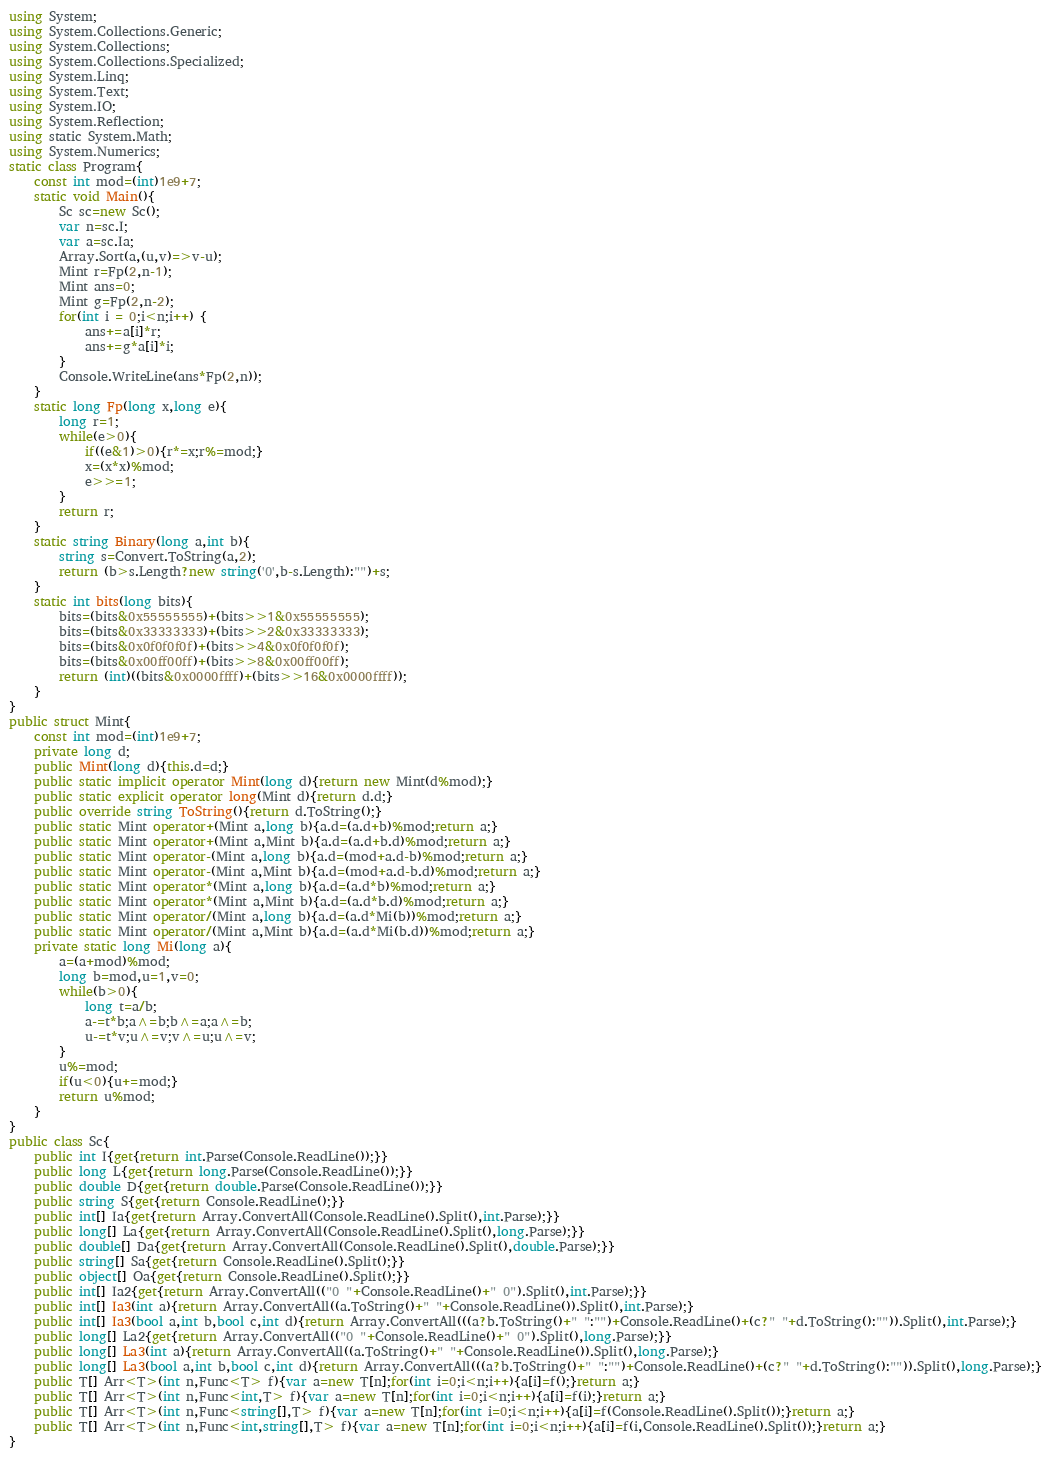<code> <loc_0><loc_0><loc_500><loc_500><_C#_>using System;
using System.Collections.Generic;
using System.Collections;
using System.Collections.Specialized;
using System.Linq;
using System.Text;
using System.IO;
using System.Reflection;
using static System.Math;
using System.Numerics;
static class Program{
	const int mod=(int)1e9+7;
	static void Main(){
		Sc sc=new Sc();
		var n=sc.I;
		var a=sc.Ia;
		Array.Sort(a,(u,v)=>v-u);
		Mint r=Fp(2,n-1);
		Mint ans=0;
		Mint g=Fp(2,n-2);
		for(int i = 0;i<n;i++) {
			ans+=a[i]*r;
			ans+=g*a[i]*i;
		}
		Console.WriteLine(ans*Fp(2,n));
	}
	static long Fp(long x,long e){
		long r=1;
		while(e>0){
			if((e&1)>0){r*=x;r%=mod;}
			x=(x*x)%mod;
			e>>=1;
		}
		return r;
	}
	static string Binary(long a,int b){
		string s=Convert.ToString(a,2);
		return (b>s.Length?new string('0',b-s.Length):"")+s;
	}
	static int bits(long bits){
		bits=(bits&0x55555555)+(bits>>1&0x55555555);
		bits=(bits&0x33333333)+(bits>>2&0x33333333);
		bits=(bits&0x0f0f0f0f)+(bits>>4&0x0f0f0f0f);
		bits=(bits&0x00ff00ff)+(bits>>8&0x00ff00ff);
		return (int)((bits&0x0000ffff)+(bits>>16&0x0000ffff));
	}
}
public struct Mint{
	const int mod=(int)1e9+7;
	private long d;
	public Mint(long d){this.d=d;}
	public static implicit operator Mint(long d){return new Mint(d%mod);}
	public static explicit operator long(Mint d){return d.d;}
	public override string ToString(){return d.ToString();}
	public static Mint operator+(Mint a,long b){a.d=(a.d+b)%mod;return a;}
	public static Mint operator+(Mint a,Mint b){a.d=(a.d+b.d)%mod;return a;}
	public static Mint operator-(Mint a,long b){a.d=(mod+a.d-b)%mod;return a;}
	public static Mint operator-(Mint a,Mint b){a.d=(mod+a.d-b.d)%mod;return a;}
	public static Mint operator*(Mint a,long b){a.d=(a.d*b)%mod;return a;}
	public static Mint operator*(Mint a,Mint b){a.d=(a.d*b.d)%mod;return a;}
	public static Mint operator/(Mint a,long b){a.d=(a.d*Mi(b))%mod;return a;}
	public static Mint operator/(Mint a,Mint b){a.d=(a.d*Mi(b.d))%mod;return a;}
	private static long Mi(long a){
		a=(a+mod)%mod;
		long b=mod,u=1,v=0;
		while(b>0){
			long t=a/b;
			a-=t*b;a^=b;b^=a;a^=b;
			u-=t*v;u^=v;v^=u;u^=v;
		}
		u%=mod;
		if(u<0){u+=mod;}
		return u%mod;
	}
}
public class Sc{
	public int I{get{return int.Parse(Console.ReadLine());}}
	public long L{get{return long.Parse(Console.ReadLine());}}
	public double D{get{return double.Parse(Console.ReadLine());}}
	public string S{get{return Console.ReadLine();}}
	public int[] Ia{get{return Array.ConvertAll(Console.ReadLine().Split(),int.Parse);}}
	public long[] La{get{return Array.ConvertAll(Console.ReadLine().Split(),long.Parse);}}
	public double[] Da{get{return Array.ConvertAll(Console.ReadLine().Split(),double.Parse);}}
	public string[] Sa{get{return Console.ReadLine().Split();}}
	public object[] Oa{get{return Console.ReadLine().Split();}}
	public int[] Ia2{get{return Array.ConvertAll(("0 "+Console.ReadLine()+" 0").Split(),int.Parse);}}
	public int[] Ia3(int a){return Array.ConvertAll((a.ToString()+" "+Console.ReadLine()).Split(),int.Parse);}
	public int[] Ia3(bool a,int b,bool c,int d){return Array.ConvertAll(((a?b.ToString()+" ":"")+Console.ReadLine()+(c?" "+d.ToString():"")).Split(),int.Parse);}
	public long[] La2{get{return Array.ConvertAll(("0 "+Console.ReadLine()+" 0").Split(),long.Parse);}}
	public long[] La3(int a){return Array.ConvertAll((a.ToString()+" "+Console.ReadLine()).Split(),long.Parse);}
	public long[] La3(bool a,int b,bool c,int d){return Array.ConvertAll(((a?b.ToString()+" ":"")+Console.ReadLine()+(c?" "+d.ToString():"")).Split(),long.Parse);}
	public T[] Arr<T>(int n,Func<T> f){var a=new T[n];for(int i=0;i<n;i++){a[i]=f();}return a;}
	public T[] Arr<T>(int n,Func<int,T> f){var a=new T[n];for(int i=0;i<n;i++){a[i]=f(i);}return a;}
	public T[] Arr<T>(int n,Func<string[],T> f){var a=new T[n];for(int i=0;i<n;i++){a[i]=f(Console.ReadLine().Split());}return a;}
	public T[] Arr<T>(int n,Func<int,string[],T> f){var a=new T[n];for(int i=0;i<n;i++){a[i]=f(i,Console.ReadLine().Split());}return a;}
}</code> 